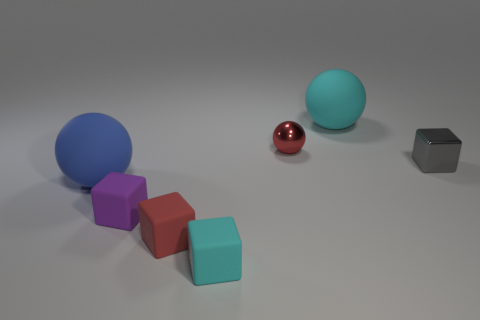Is the number of shiny spheres behind the red metallic ball less than the number of cubes that are behind the small cyan object?
Provide a succinct answer. Yes. There is a tiny gray block; how many small things are to the right of it?
Keep it short and to the point. 0. Is the shape of the matte object that is to the right of the shiny sphere the same as the large matte thing in front of the gray shiny thing?
Offer a very short reply. Yes. How many other objects are the same color as the metal sphere?
Your answer should be compact. 1. What material is the large thing that is left of the cyan matte thing in front of the object that is on the left side of the purple thing?
Make the answer very short. Rubber. What is the material of the big thing to the right of the matte ball that is in front of the large cyan sphere?
Your answer should be compact. Rubber. Is the number of shiny spheres that are in front of the blue matte object less than the number of tiny matte cylinders?
Provide a succinct answer. No. What shape is the rubber object behind the red metallic sphere?
Your answer should be very brief. Sphere. There is a cyan matte cube; is its size the same as the metal object in front of the tiny ball?
Your answer should be very brief. Yes. Are there any other cyan balls made of the same material as the cyan ball?
Your answer should be compact. No. 